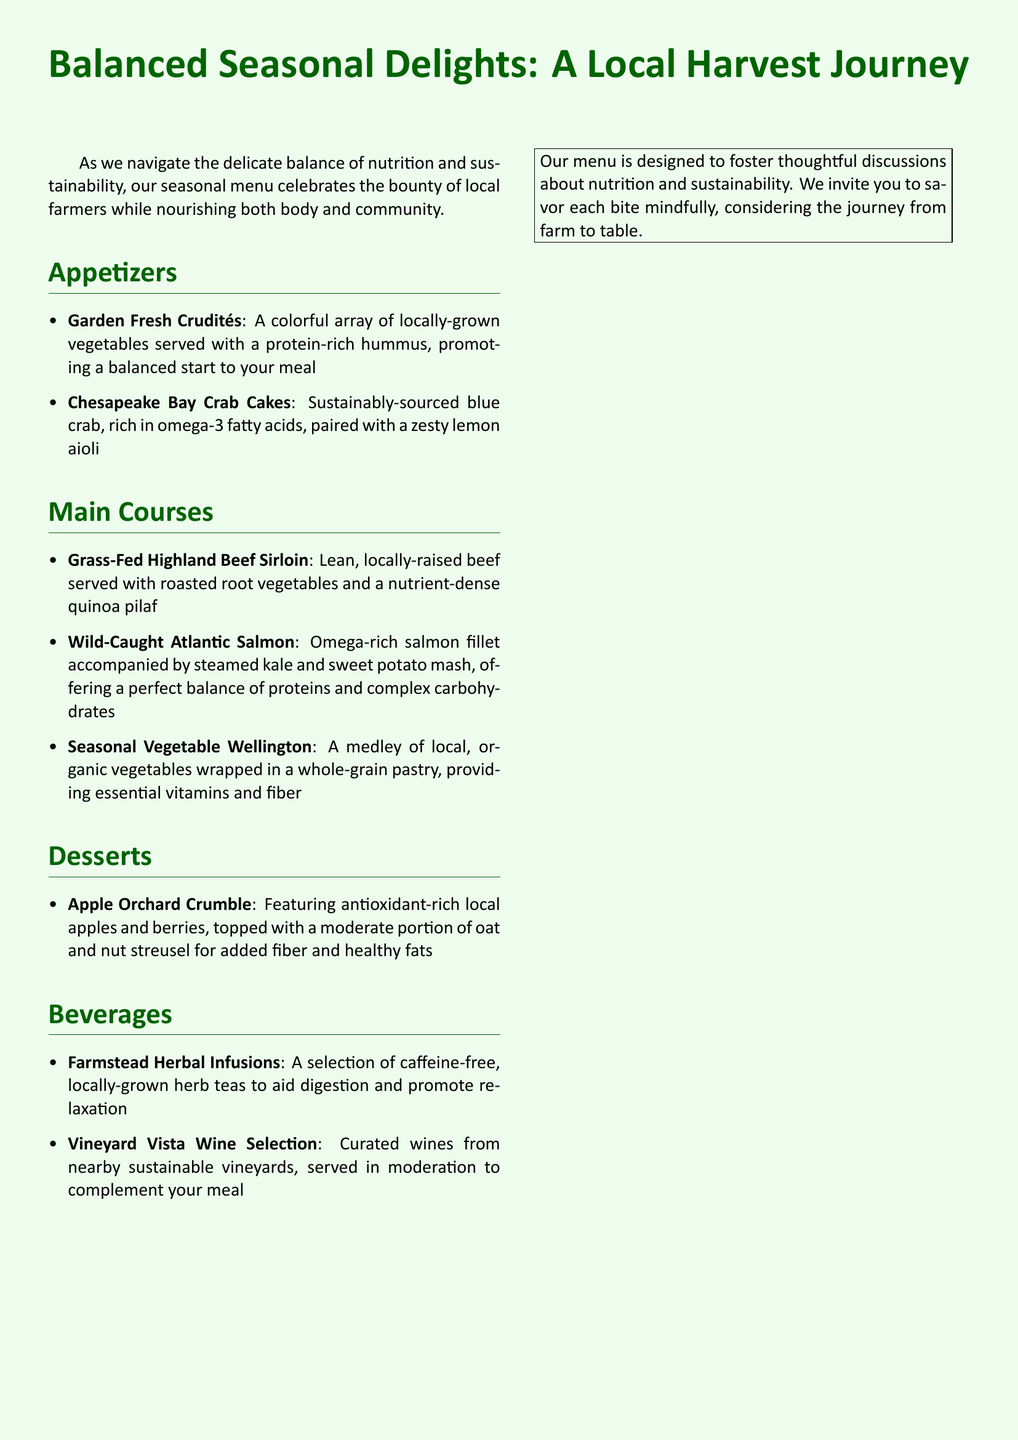What are the appetizers listed on the menu? The appetizers are listed in the 'Appetizers' section of the menu, which includes Garden Fresh Crudités and Chesapeake Bay Crab Cakes.
Answer: Garden Fresh Crudités, Chesapeake Bay Crab Cakes What main course features omega-rich fish? The document specifies that Wild-Caught Atlantic Salmon is the main course that features omega-rich fish.
Answer: Wild-Caught Atlantic Salmon What ingredients are in the Seasonal Vegetable Wellington? The ingredients for this dish are detailed in the menu under the main courses, noting it includes local, organic vegetables and a whole-grain pastry.
Answer: Local, organic vegetables, whole-grain pastry Which dessert is made with local apples? The dessert section mentions the Apple Orchard Crumble made with local apples and berries.
Answer: Apple Orchard Crumble What type of herbal beverages are offered? The document indicates that there is a selection of caffeine-free, locally-grown herb teas available for digestion and relaxation.
Answer: Farmstead Herbal Infusions How many main courses are listed on the menu? The number of main courses can be counted from the document, which lists three main course options.
Answer: Three What is the focus of the seasonal menu? The menu states that it celebrates the bounty of local farmers while nourishing both body and community.
Answer: Balanced nutrition, locally-sourced ingredients What is used to complement the meals from the Vineyard Vista Wine Selection? The menu describes the Vineyard Vista Wine Selection as curated wines served in moderation to complement meals.
Answer: Moderation 